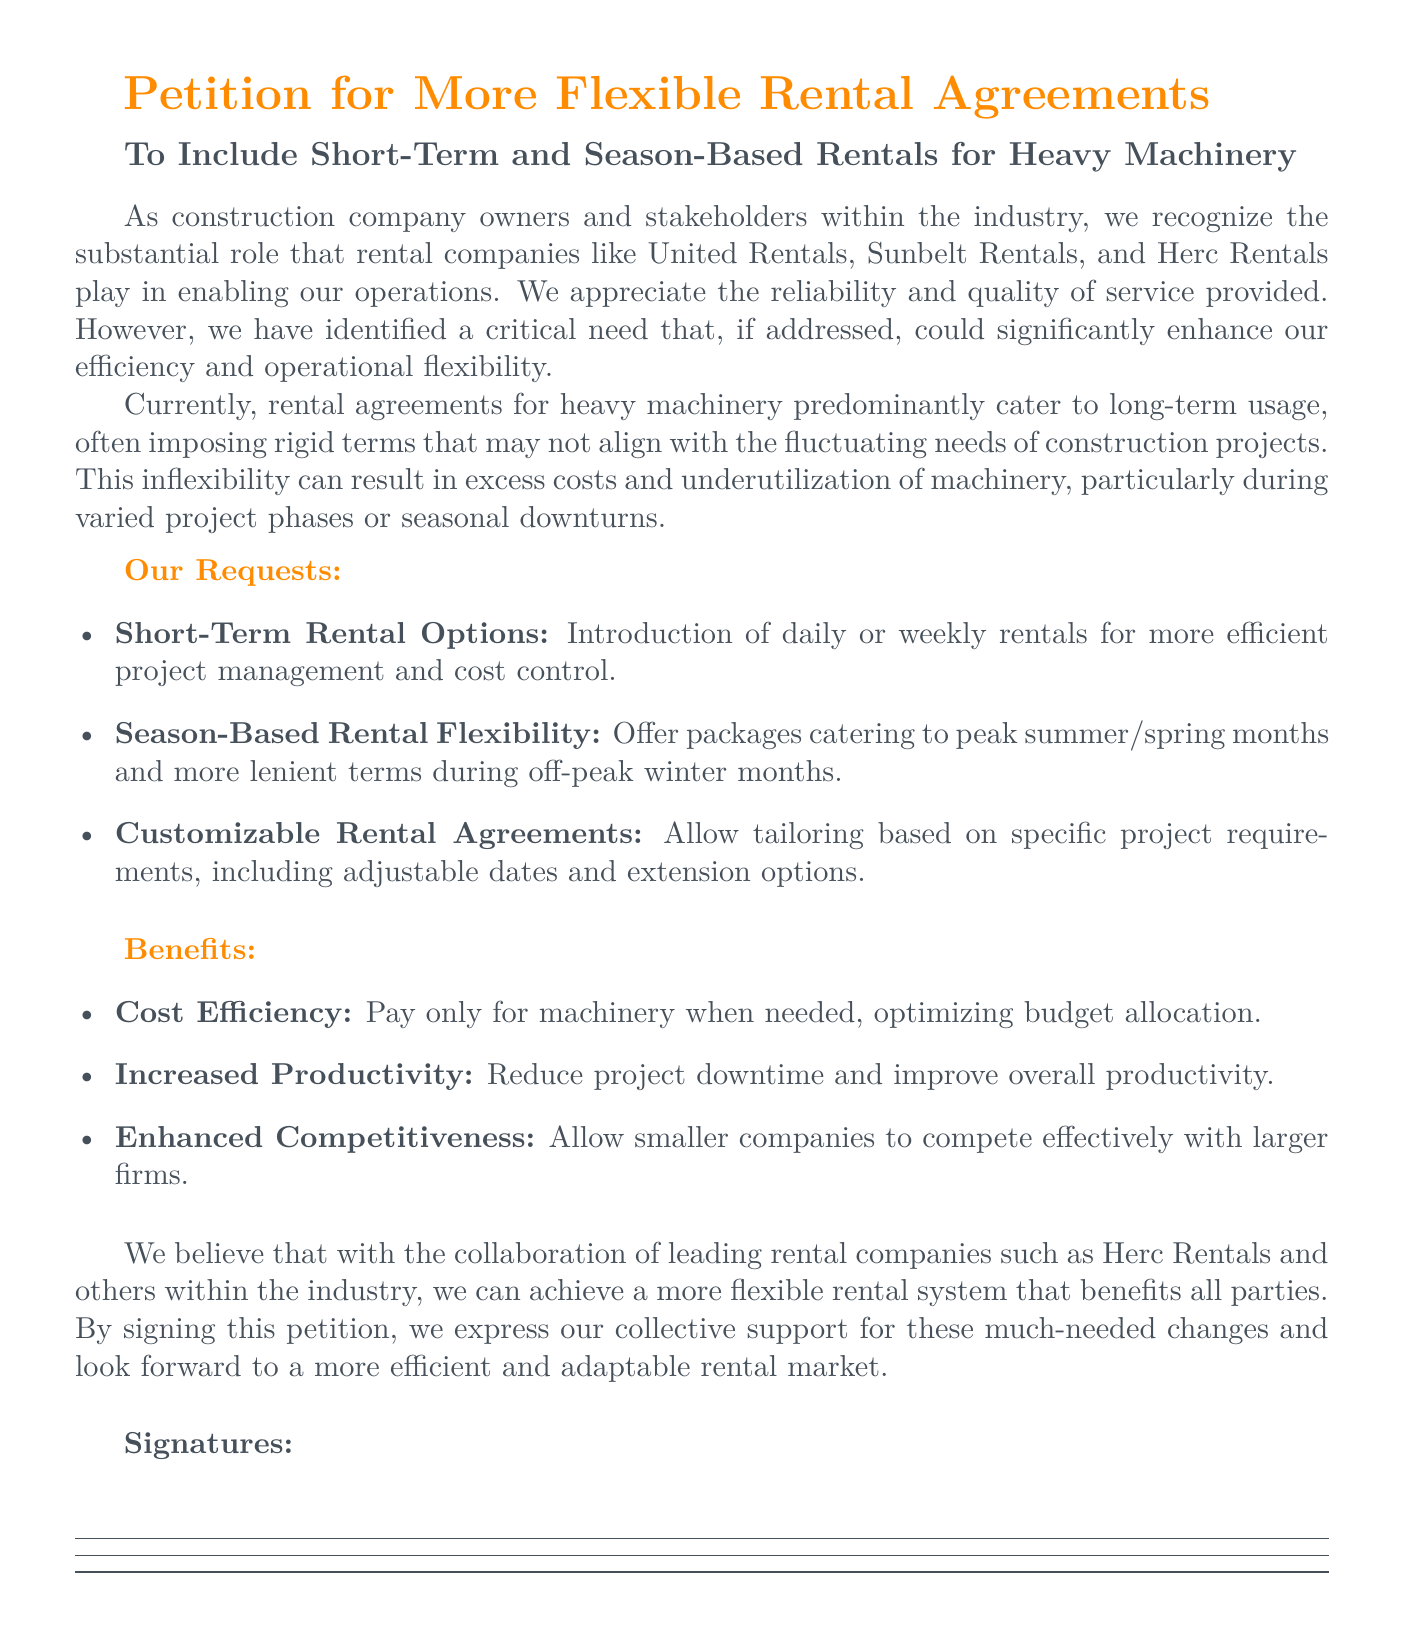What is the title of the petition? The title of the petition is prominently stated at the beginning of the document.
Answer: Petition for More Flexible Rental Agreements What are the three main requests made in the petition? The main requests are listed as bullet points in the document.
Answer: Short-Term Rental Options, Season-Based Rental Flexibility, Customizable Rental Agreements Who are the rental companies mentioned in the document? The rental companies are mentioned in the introductory part of the petition.
Answer: United Rentals, Sunbelt Rentals, Herc Rentals What benefit is associated with reducing project downtime? The benefit is directly linked to the overall productivity of construction projects as stated in the document.
Answer: Increased Productivity What does the petition aim to achieve with collaboration? The expected outcome of collaboration is explicitly stated towards the end of the document.
Answer: A more flexible rental system What color is used for the section titles? The document specifies a distinct color for section titles in the formatting.
Answer: Construction orange What type of rental options does the petition emphasize need to be introduced? This type of rental option is a part of the core requests mentioned in the document.
Answer: Daily or weekly rentals Which season-based flexibility is mentioned in the document? The specific seasons referenced are found in the requests for rental flexibilities.
Answer: Summer/spring and off-peak winter months What is the purpose of signing the petition? The purpose of signing is indicated in the conclusion of the document.
Answer: Express collective support for changes 